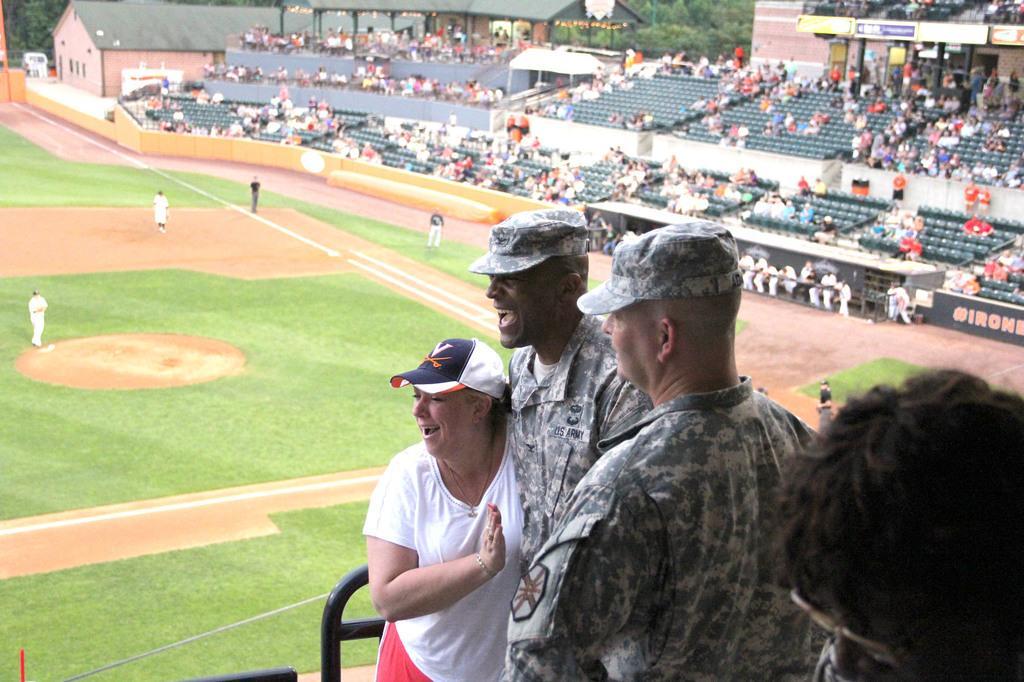Describe this image in one or two sentences. In the picture we can see a playground with some green color mats on it with some people standing in a sports wear and behind them we can see audience sitting in the chairs and watching them and beside them we can see a house and behind it we can see a shed and behind it we can see trees and near the picture we can see two army men and one woman are standing. 